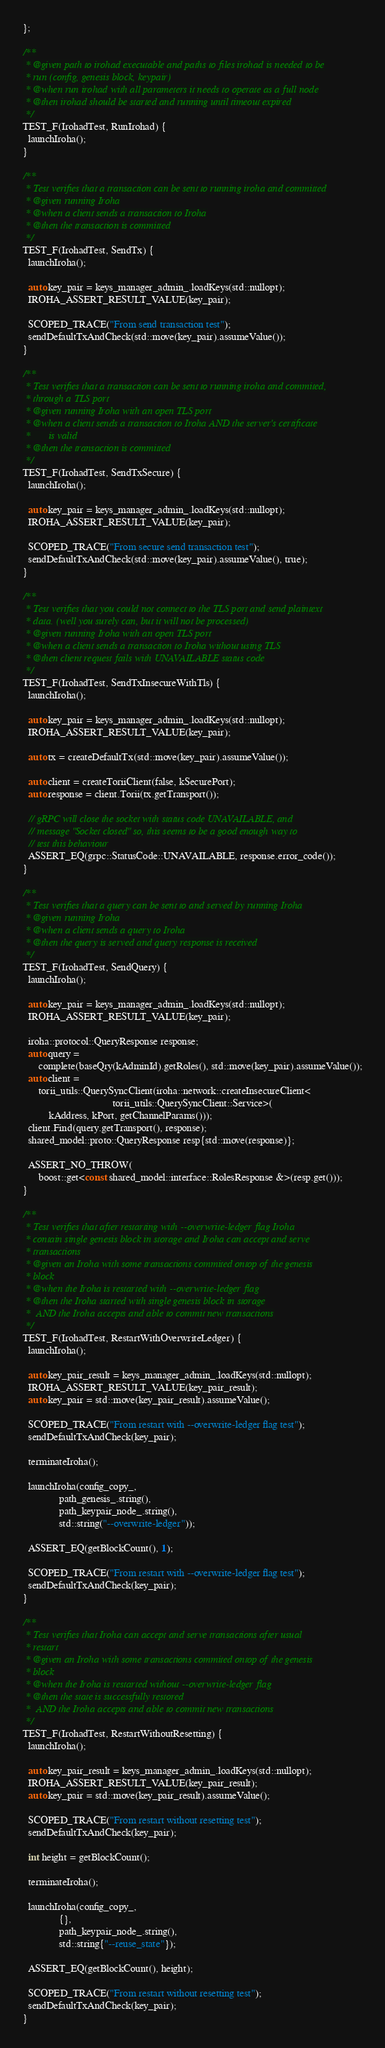Convert code to text. <code><loc_0><loc_0><loc_500><loc_500><_C++_>};

/**
 * @given path to irohad executable and paths to files irohad is needed to be
 * run (config, genesis block, keypair)
 * @when run irohad with all parameters it needs to operate as a full node
 * @then irohad should be started and running until timeout expired
 */
TEST_F(IrohadTest, RunIrohad) {
  launchIroha();
}

/**
 * Test verifies that a transaction can be sent to running iroha and committed
 * @given running Iroha
 * @when a client sends a transaction to Iroha
 * @then the transaction is committed
 */
TEST_F(IrohadTest, SendTx) {
  launchIroha();

  auto key_pair = keys_manager_admin_.loadKeys(std::nullopt);
  IROHA_ASSERT_RESULT_VALUE(key_pair);

  SCOPED_TRACE("From send transaction test");
  sendDefaultTxAndCheck(std::move(key_pair).assumeValue());
}

/**
 * Test verifies that a transaction can be sent to running iroha and commited,
 * through a TLS port
 * @given running Iroha with an open TLS port
 * @when a client sends a transaction to Iroha AND the server's certificate
 *       is valid
 * @then the transaction is committed
 */
TEST_F(IrohadTest, SendTxSecure) {
  launchIroha();

  auto key_pair = keys_manager_admin_.loadKeys(std::nullopt);
  IROHA_ASSERT_RESULT_VALUE(key_pair);

  SCOPED_TRACE("From secure send transaction test");
  sendDefaultTxAndCheck(std::move(key_pair).assumeValue(), true);
}

/**
 * Test verifies that you could not connect to the TLS port and send plaintext
 * data. (well you surely can, but it will not be processed)
 * @given running Iroha with an open TLS port
 * @when a client sends a transaction to Iroha without using TLS
 * @then client request fails with UNAVAILABLE status code
 */
TEST_F(IrohadTest, SendTxInsecureWithTls) {
  launchIroha();

  auto key_pair = keys_manager_admin_.loadKeys(std::nullopt);
  IROHA_ASSERT_RESULT_VALUE(key_pair);

  auto tx = createDefaultTx(std::move(key_pair).assumeValue());

  auto client = createToriiClient(false, kSecurePort);
  auto response = client.Torii(tx.getTransport());

  // gRPC will close the socket with status code UNAVAILABLE, and
  // message "Socket closed" so, this seems to be a good enough way to
  // test this behaviour
  ASSERT_EQ(grpc::StatusCode::UNAVAILABLE, response.error_code());
}

/**
 * Test verifies that a query can be sent to and served by running Iroha
 * @given running Iroha
 * @when a client sends a query to Iroha
 * @then the query is served and query response is received
 */
TEST_F(IrohadTest, SendQuery) {
  launchIroha();

  auto key_pair = keys_manager_admin_.loadKeys(std::nullopt);
  IROHA_ASSERT_RESULT_VALUE(key_pair);

  iroha::protocol::QueryResponse response;
  auto query =
      complete(baseQry(kAdminId).getRoles(), std::move(key_pair).assumeValue());
  auto client =
      torii_utils::QuerySyncClient(iroha::network::createInsecureClient<
                                   torii_utils::QuerySyncClient::Service>(
          kAddress, kPort, getChannelParams()));
  client.Find(query.getTransport(), response);
  shared_model::proto::QueryResponse resp{std::move(response)};

  ASSERT_NO_THROW(
      boost::get<const shared_model::interface::RolesResponse &>(resp.get()));
}

/**
 * Test verifies that after restarting with --overwrite-ledger flag Iroha
 * contain single genesis block in storage and Iroha can accept and serve
 * transactions
 * @given an Iroha with some transactions commited ontop of the genesis
 * block
 * @when the Iroha is restarted with --overwrite-ledger flag
 * @then the Iroha started with single genesis block in storage
 *  AND the Iroha accepts and able to commit new transactions
 */
TEST_F(IrohadTest, RestartWithOverwriteLedger) {
  launchIroha();

  auto key_pair_result = keys_manager_admin_.loadKeys(std::nullopt);
  IROHA_ASSERT_RESULT_VALUE(key_pair_result);
  auto key_pair = std::move(key_pair_result).assumeValue();

  SCOPED_TRACE("From restart with --overwrite-ledger flag test");
  sendDefaultTxAndCheck(key_pair);

  terminateIroha();

  launchIroha(config_copy_,
              path_genesis_.string(),
              path_keypair_node_.string(),
              std::string("--overwrite-ledger"));

  ASSERT_EQ(getBlockCount(), 1);

  SCOPED_TRACE("From restart with --overwrite-ledger flag test");
  sendDefaultTxAndCheck(key_pair);
}

/**
 * Test verifies that Iroha can accept and serve transactions after usual
 * restart
 * @given an Iroha with some transactions commited ontop of the genesis
 * block
 * @when the Iroha is restarted without --overwrite-ledger flag
 * @then the state is successfully restored
 *  AND the Iroha accepts and able to commit new transactions
 */
TEST_F(IrohadTest, RestartWithoutResetting) {
  launchIroha();

  auto key_pair_result = keys_manager_admin_.loadKeys(std::nullopt);
  IROHA_ASSERT_RESULT_VALUE(key_pair_result);
  auto key_pair = std::move(key_pair_result).assumeValue();

  SCOPED_TRACE("From restart without resetting test");
  sendDefaultTxAndCheck(key_pair);

  int height = getBlockCount();

  terminateIroha();

  launchIroha(config_copy_,
              {},
              path_keypair_node_.string(),
              std::string{"--reuse_state"});

  ASSERT_EQ(getBlockCount(), height);

  SCOPED_TRACE("From restart without resetting test");
  sendDefaultTxAndCheck(key_pair);
}
</code> 